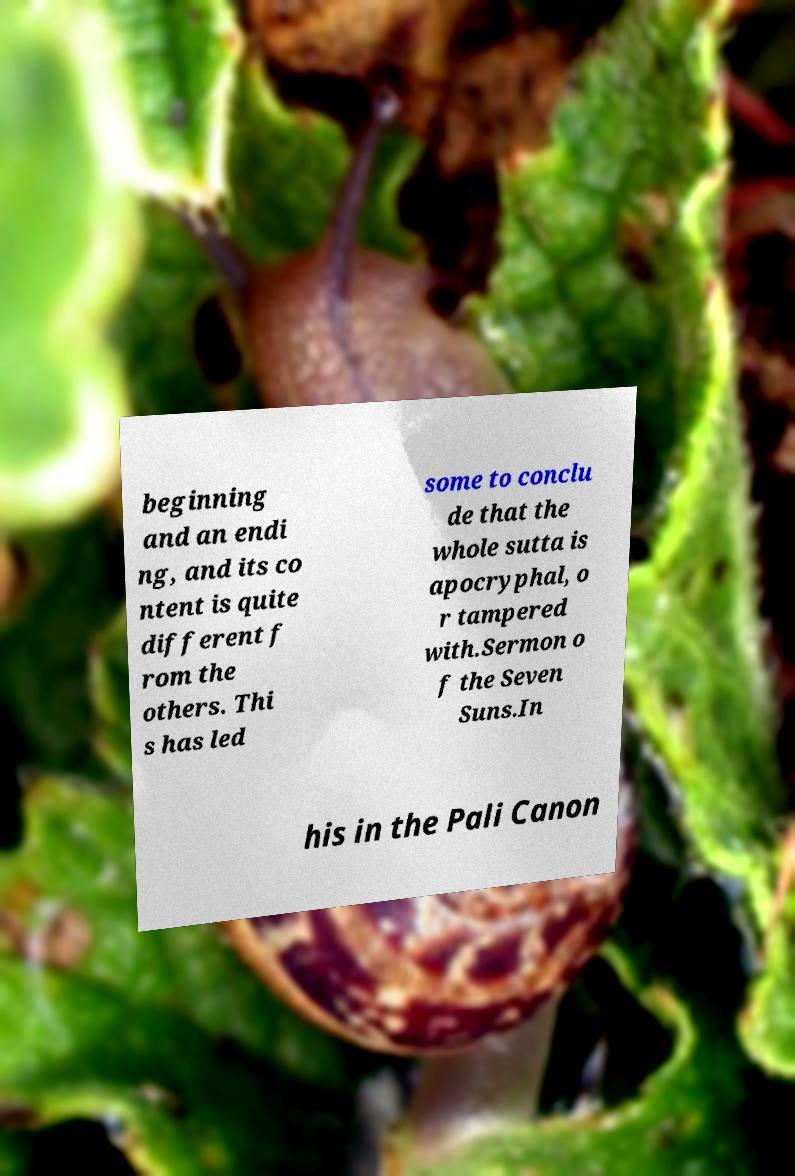What messages or text are displayed in this image? I need them in a readable, typed format. beginning and an endi ng, and its co ntent is quite different f rom the others. Thi s has led some to conclu de that the whole sutta is apocryphal, o r tampered with.Sermon o f the Seven Suns.In his in the Pali Canon 